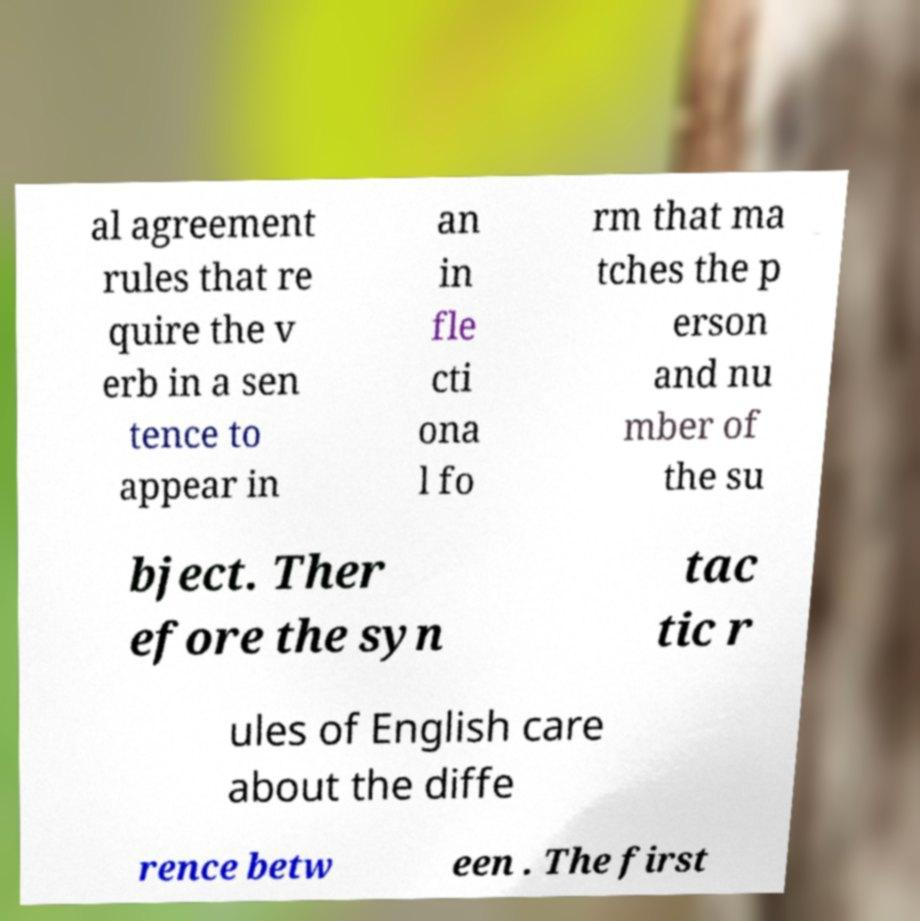I need the written content from this picture converted into text. Can you do that? al agreement rules that re quire the v erb in a sen tence to appear in an in fle cti ona l fo rm that ma tches the p erson and nu mber of the su bject. Ther efore the syn tac tic r ules of English care about the diffe rence betw een . The first 